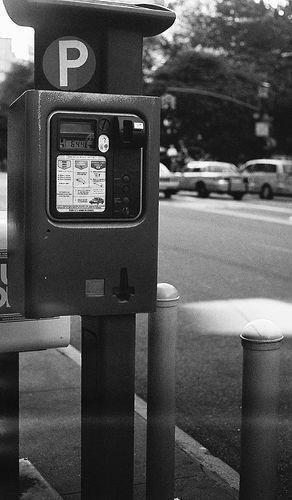How many times does the letter P show up in this image?
Give a very brief answer. 1. How many parking meters are there?
Give a very brief answer. 1. 